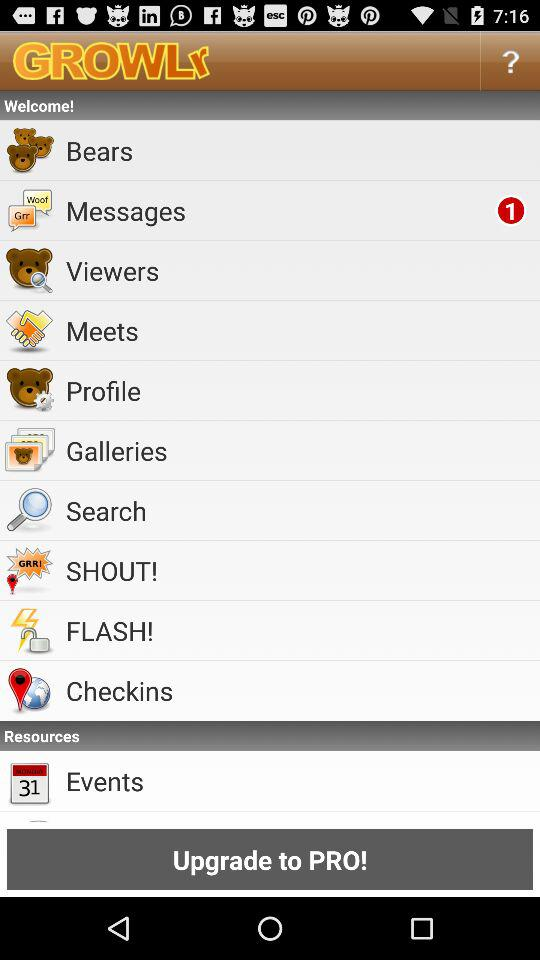What is the name of the application? The name of the application is "GROWLr". 